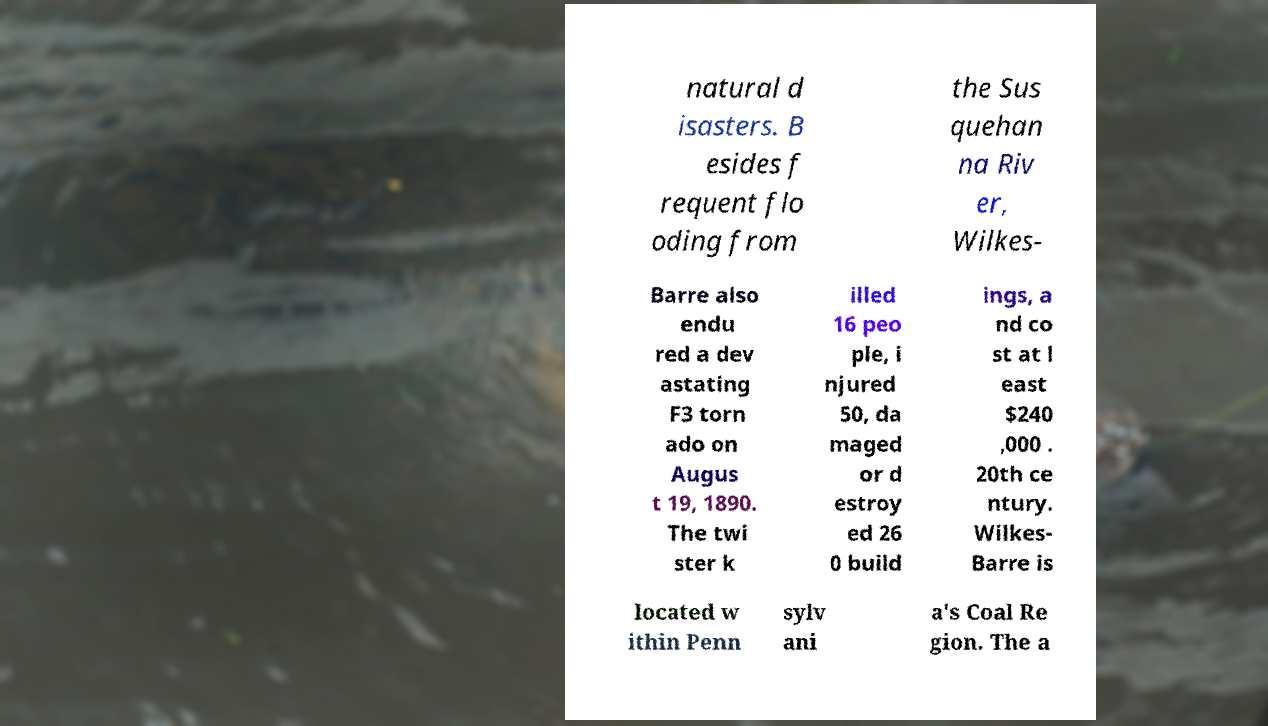I need the written content from this picture converted into text. Can you do that? natural d isasters. B esides f requent flo oding from the Sus quehan na Riv er, Wilkes- Barre also endu red a dev astating F3 torn ado on Augus t 19, 1890. The twi ster k illed 16 peo ple, i njured 50, da maged or d estroy ed 26 0 build ings, a nd co st at l east $240 ,000 . 20th ce ntury. Wilkes- Barre is located w ithin Penn sylv ani a's Coal Re gion. The a 